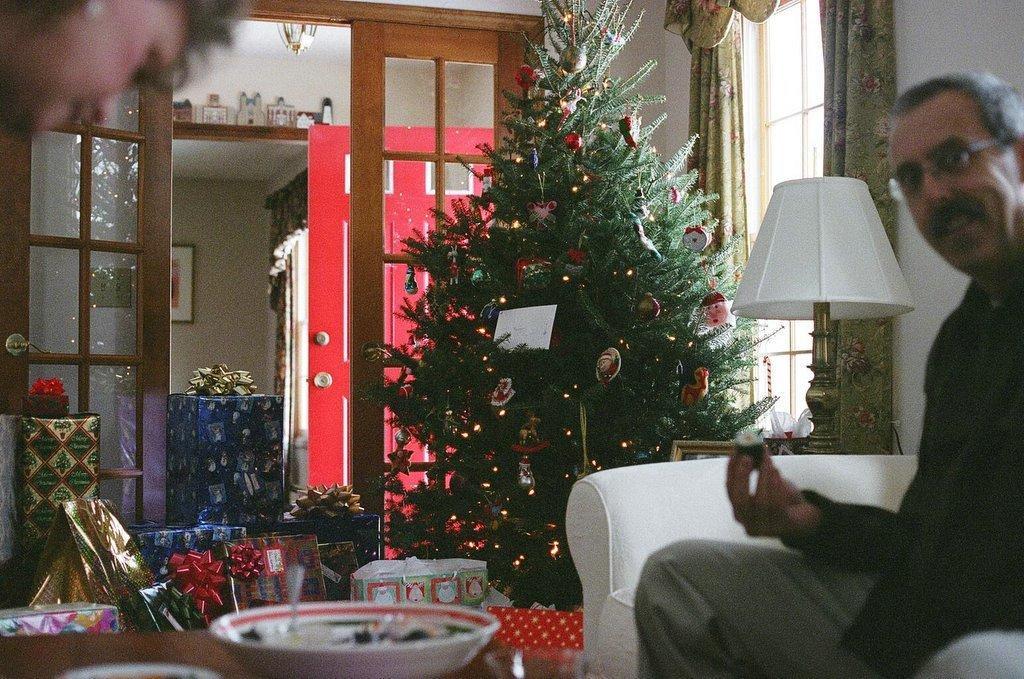Describe this image in one or two sentences. In this image, we can see a person sitting on the sofa and wearing glasses and holding an object. In the background, there is a lamp and we can see a christmas tree and some gifts and there is a bowl with food and a spoon and some other objects are placed on the table and we can see a lady and there is a door, a window, curtain, a paper and some other objects and a frame on the wall. 